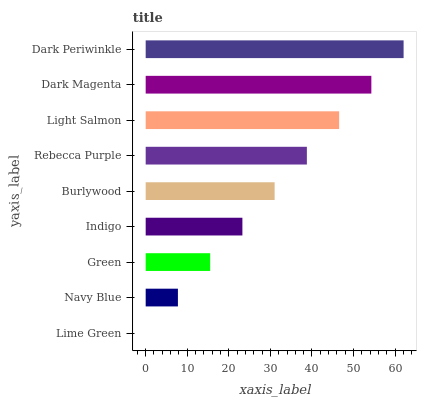Is Lime Green the minimum?
Answer yes or no. Yes. Is Dark Periwinkle the maximum?
Answer yes or no. Yes. Is Navy Blue the minimum?
Answer yes or no. No. Is Navy Blue the maximum?
Answer yes or no. No. Is Navy Blue greater than Lime Green?
Answer yes or no. Yes. Is Lime Green less than Navy Blue?
Answer yes or no. Yes. Is Lime Green greater than Navy Blue?
Answer yes or no. No. Is Navy Blue less than Lime Green?
Answer yes or no. No. Is Burlywood the high median?
Answer yes or no. Yes. Is Burlywood the low median?
Answer yes or no. Yes. Is Light Salmon the high median?
Answer yes or no. No. Is Green the low median?
Answer yes or no. No. 